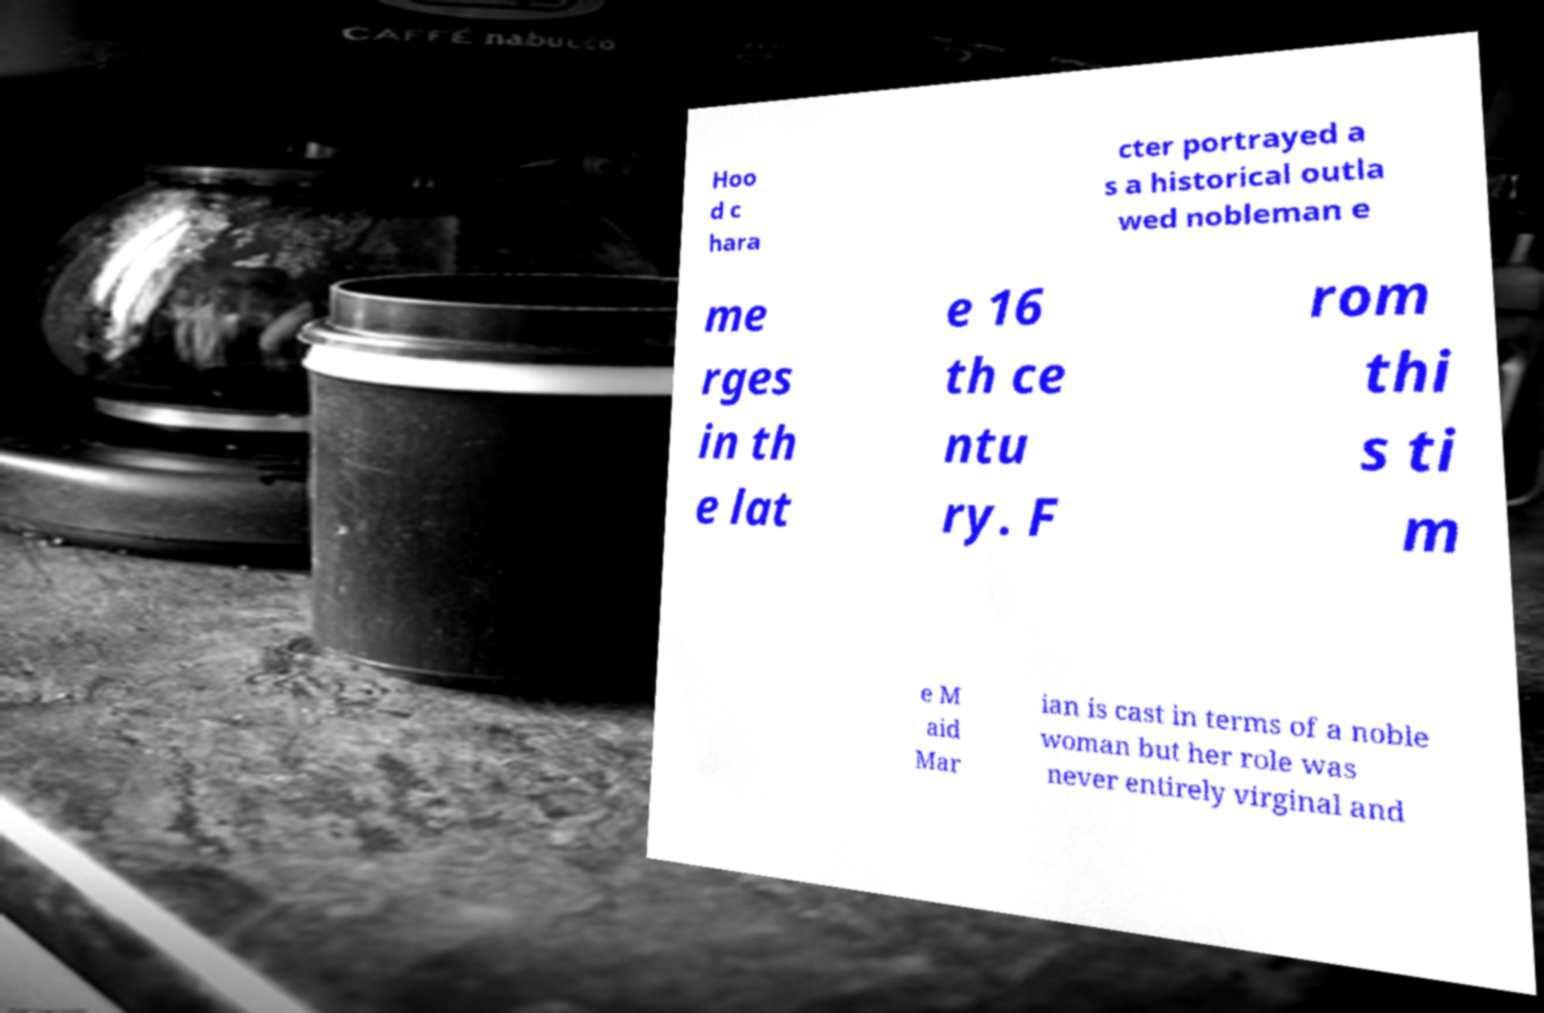I need the written content from this picture converted into text. Can you do that? Hoo d c hara cter portrayed a s a historical outla wed nobleman e me rges in th e lat e 16 th ce ntu ry. F rom thi s ti m e M aid Mar ian is cast in terms of a noble woman but her role was never entirely virginal and 